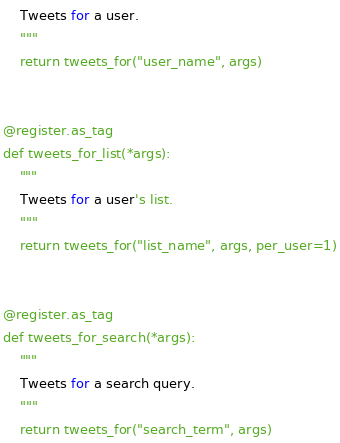<code> <loc_0><loc_0><loc_500><loc_500><_Python_>    Tweets for a user.
    """
    return tweets_for("user_name", args)


@register.as_tag
def tweets_for_list(*args):
    """
    Tweets for a user's list.
    """
    return tweets_for("list_name", args, per_user=1)


@register.as_tag
def tweets_for_search(*args):
    """
    Tweets for a search query.
    """
    return tweets_for("search_term", args)
</code> 